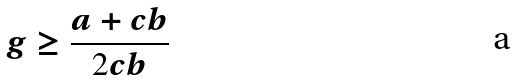Convert formula to latex. <formula><loc_0><loc_0><loc_500><loc_500>g \geq \frac { a + c b } { 2 c b }</formula> 